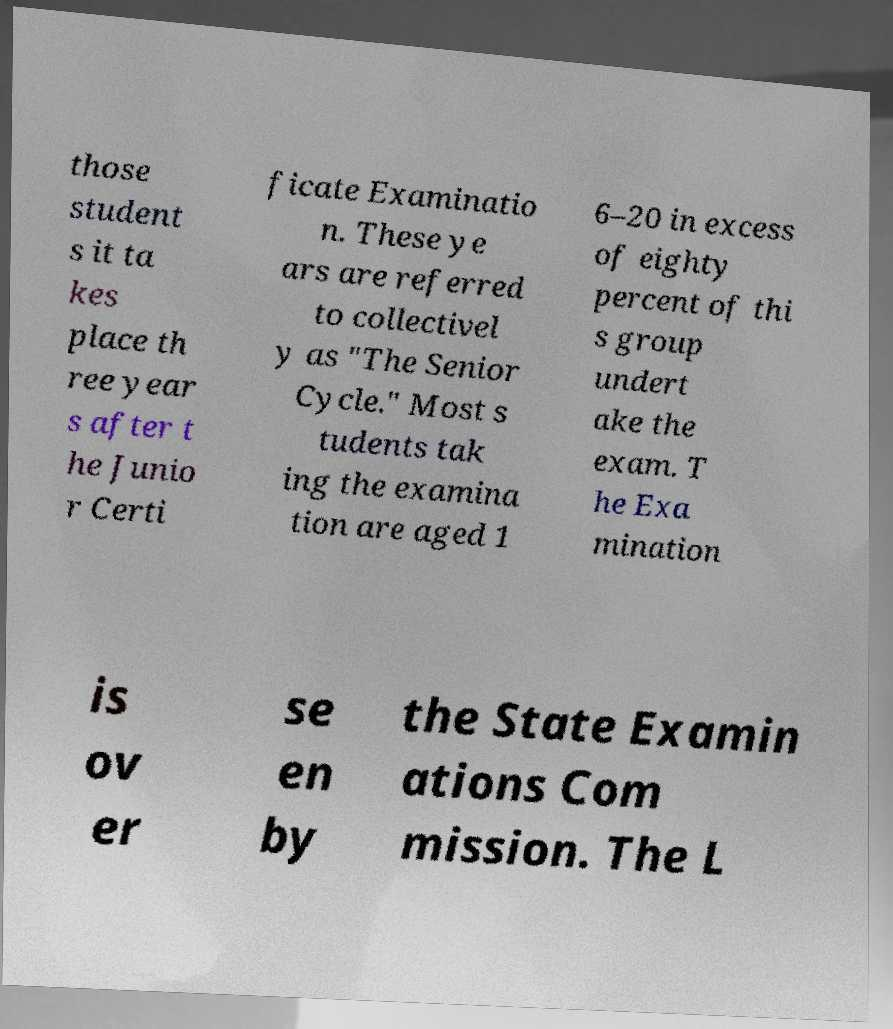Please read and relay the text visible in this image. What does it say? those student s it ta kes place th ree year s after t he Junio r Certi ficate Examinatio n. These ye ars are referred to collectivel y as "The Senior Cycle." Most s tudents tak ing the examina tion are aged 1 6–20 in excess of eighty percent of thi s group undert ake the exam. T he Exa mination is ov er se en by the State Examin ations Com mission. The L 